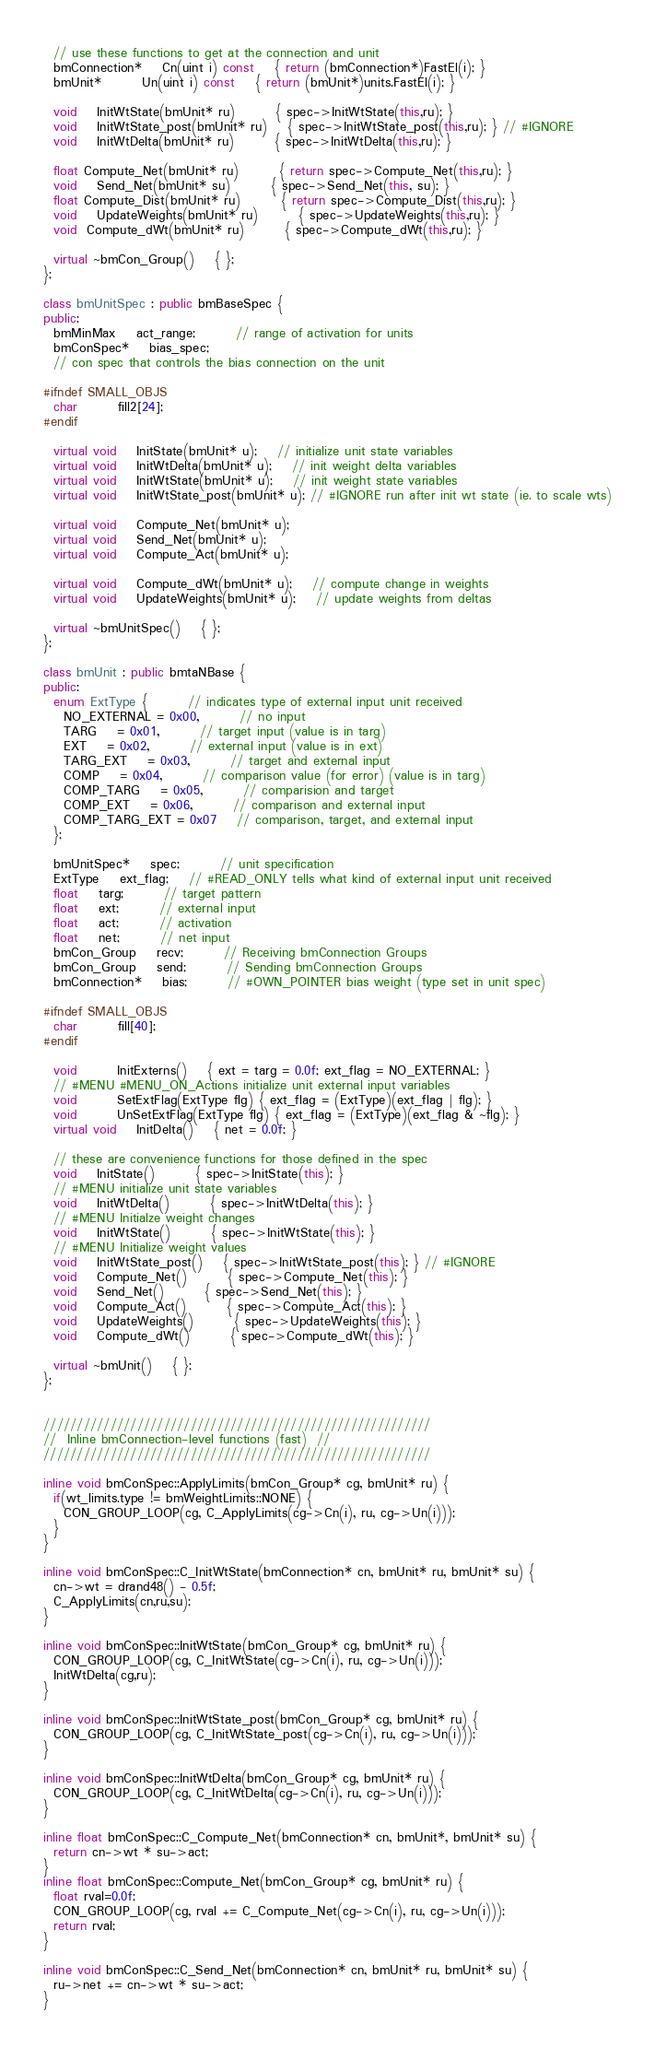<code> <loc_0><loc_0><loc_500><loc_500><_C++_>  // use these functions to get at the connection and unit
  bmConnection* 	Cn(uint i) const 	{ return (bmConnection*)FastEl(i); }
  bmUnit*		Un(uint i) const 	{ return (bmUnit*)units.FastEl(i); }

  void 	InitWtState(bmUnit* ru)	 	{ spec->InitWtState(this,ru); }
  void	InitWtState_post(bmUnit* ru) 	{ spec->InitWtState_post(this,ru); } // #IGNORE
  void 	InitWtDelta(bmUnit* ru)	 	{ spec->InitWtDelta(this,ru); }

  float Compute_Net(bmUnit* ru)	 	{ return spec->Compute_Net(this,ru); }
  void 	Send_Net(bmUnit* su)		{ spec->Send_Net(this, su); }
  float Compute_Dist(bmUnit* ru)	 	{ return spec->Compute_Dist(this,ru); }
  void 	UpdateWeights(bmUnit* ru)	 	{ spec->UpdateWeights(this,ru); }
  void  Compute_dWt(bmUnit* ru)	 	{ spec->Compute_dWt(this,ru); }

  virtual ~bmCon_Group()	{ };
};

class bmUnitSpec : public bmBaseSpec {
public:
  bmMinMax	act_range;		// range of activation for units
  bmConSpec*	bias_spec;
  // con spec that controls the bias connection on the unit

#ifndef SMALL_OBJS
  char		fill2[24];
#endif

  virtual void 	InitState(bmUnit* u);	// initialize unit state variables
  virtual void 	InitWtDelta(bmUnit* u); 	// init weight delta variables
  virtual void 	InitWtState(bmUnit* u); 	// init weight state variables
  virtual void	InitWtState_post(bmUnit* u); // #IGNORE run after init wt state (ie. to scale wts)

  virtual void 	Compute_Net(bmUnit* u);
  virtual void 	Send_Net(bmUnit* u);
  virtual void 	Compute_Act(bmUnit* u);

  virtual void 	Compute_dWt(bmUnit* u); 	// compute change in weights
  virtual void 	UpdateWeights(bmUnit* u);	// update weights from deltas

  virtual ~bmUnitSpec()	{ };
};

class bmUnit : public bmtaNBase {
public:
  enum ExtType {		// indicates type of external input unit received
    NO_EXTERNAL = 0x00,		// no input
    TARG 	= 0x01,		// target input (value is in targ)
    EXT 	= 0x02,		// external input (value is in ext)
    TARG_EXT 	= 0x03,		// target and external input
    COMP	= 0x04,		// comparison value (for error) (value is in targ)
    COMP_TARG	= 0x05,		// comparision and target
    COMP_EXT	= 0x06,		// comparison and external input
    COMP_TARG_EXT = 0x07 	// comparison, target, and external input
  };

  bmUnitSpec*	spec;		// unit specification
  ExtType	ext_flag;	// #READ_ONLY tells what kind of external input unit received
  float 	targ;		// target pattern
  float 	ext;		// external input
  float 	act;		// activation
  float 	net;		// net input
  bmCon_Group 	recv;		// Receiving bmConnection Groups
  bmCon_Group 	send;		// Sending bmConnection Groups
  bmConnection*	bias;		// #OWN_POINTER bias weight (type set in unit spec)

#ifndef SMALL_OBJS
  char		fill[40];
#endif

  void 		InitExterns()	{ ext = targ = 0.0f; ext_flag = NO_EXTERNAL; }
  // #MENU #MENU_ON_Actions initialize unit external input variables
  void		SetExtFlag(ExtType flg) { ext_flag = (ExtType)(ext_flag | flg); }
  void		UnSetExtFlag(ExtType flg) { ext_flag = (ExtType)(ext_flag & ~flg); }
  virtual void 	InitDelta()	{ net = 0.0f; }

  // these are convenience functions for those defined in the spec
  void 	InitState()		{ spec->InitState(this); }
  // #MENU initialize unit state variables
  void 	InitWtDelta()		{ spec->InitWtDelta(this); }
  // #MENU Initialze weight changes
  void 	InitWtState()		{ spec->InitWtState(this); }
  // #MENU Initialize weight values
  void	InitWtState_post() 	{ spec->InitWtState_post(this); } // #IGNORE
  void 	Compute_Net()		{ spec->Compute_Net(this); }	 
  void 	Send_Net()		{ spec->Send_Net(this); }	  
  void 	Compute_Act()		{ spec->Compute_Act(this); }	  
  void 	UpdateWeights()		{ spec->UpdateWeights(this); }	  
  void 	Compute_dWt()		{ spec->Compute_dWt(this); }	  

  virtual ~bmUnit()	{ };
};


//////////////////////////////////////////////////////////
// 	Inline bmConnection-level functions (fast)	//
//////////////////////////////////////////////////////////

inline void bmConSpec::ApplyLimits(bmCon_Group* cg, bmUnit* ru) {
  if(wt_limits.type != bmWeightLimits::NONE) {
    CON_GROUP_LOOP(cg, C_ApplyLimits(cg->Cn(i), ru, cg->Un(i)));
  }
}

inline void bmConSpec::C_InitWtState(bmConnection* cn, bmUnit* ru, bmUnit* su) {
  cn->wt = drand48() - 0.5f;
  C_ApplyLimits(cn,ru,su);
}

inline void bmConSpec::InitWtState(bmCon_Group* cg, bmUnit* ru) {
  CON_GROUP_LOOP(cg, C_InitWtState(cg->Cn(i), ru, cg->Un(i)));
  InitWtDelta(cg,ru);
}

inline void bmConSpec::InitWtState_post(bmCon_Group* cg, bmUnit* ru) {
  CON_GROUP_LOOP(cg, C_InitWtState_post(cg->Cn(i), ru, cg->Un(i)));
}

inline void bmConSpec::InitWtDelta(bmCon_Group* cg, bmUnit* ru) {
  CON_GROUP_LOOP(cg, C_InitWtDelta(cg->Cn(i), ru, cg->Un(i)));
}

inline float bmConSpec::C_Compute_Net(bmConnection* cn, bmUnit*, bmUnit* su) {
  return cn->wt * su->act;
}
inline float bmConSpec::Compute_Net(bmCon_Group* cg, bmUnit* ru) {
  float rval=0.0f;
  CON_GROUP_LOOP(cg, rval += C_Compute_Net(cg->Cn(i), ru, cg->Un(i)));
  return rval;
}

inline void bmConSpec::C_Send_Net(bmConnection* cn, bmUnit* ru, bmUnit* su) {
  ru->net += cn->wt * su->act;
}</code> 